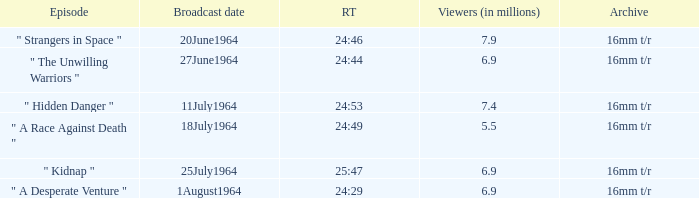What is run time when there were 7.4 million viewers? 24:53. 